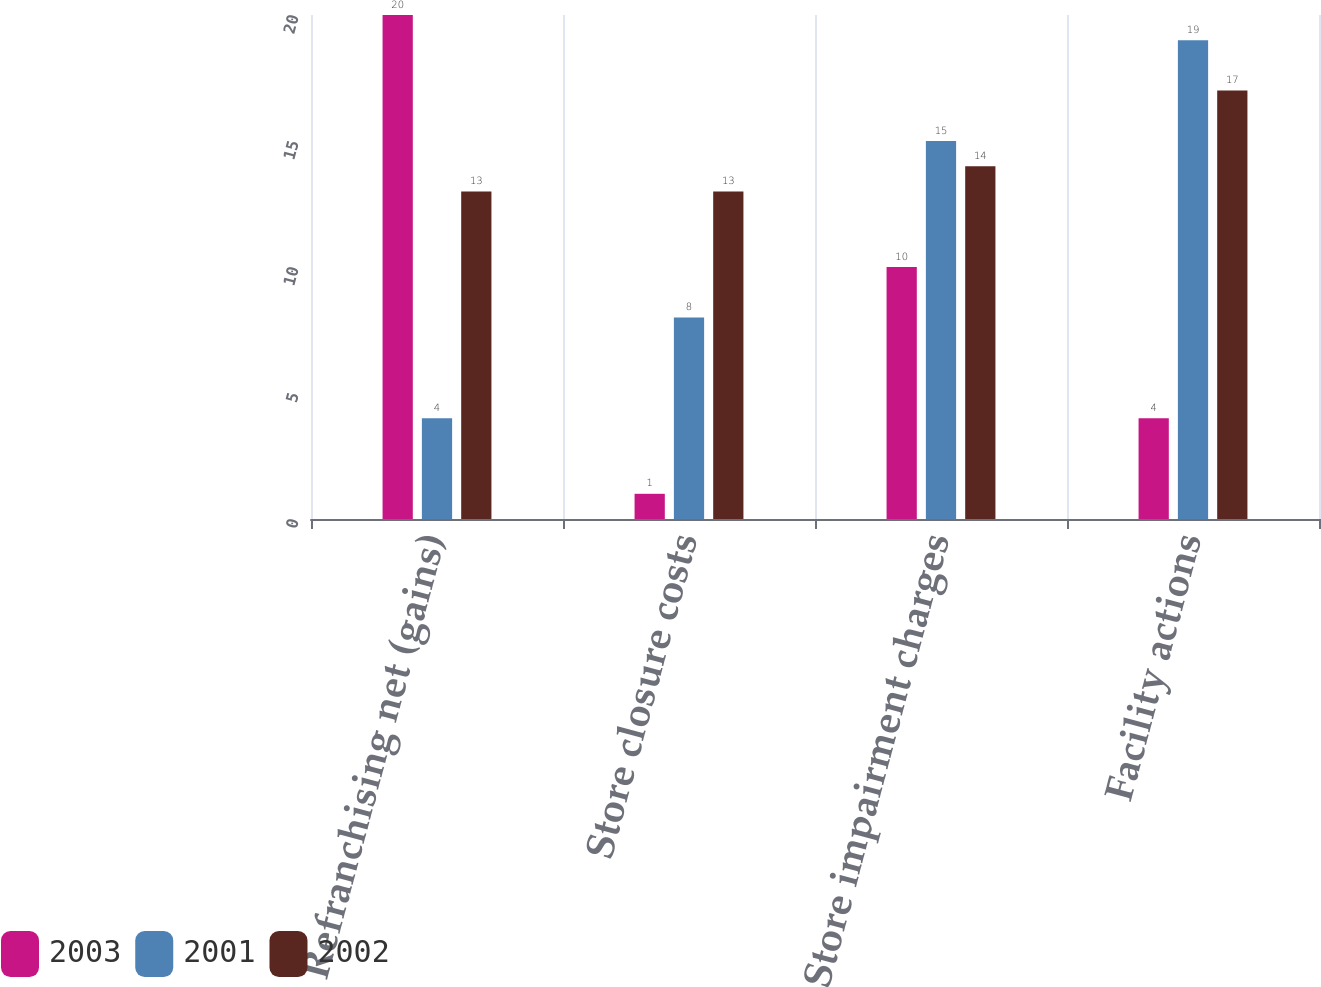Convert chart to OTSL. <chart><loc_0><loc_0><loc_500><loc_500><stacked_bar_chart><ecel><fcel>Refranchising net (gains)<fcel>Store closure costs<fcel>Store impairment charges<fcel>Facility actions<nl><fcel>2003<fcel>20<fcel>1<fcel>10<fcel>4<nl><fcel>2001<fcel>4<fcel>8<fcel>15<fcel>19<nl><fcel>2002<fcel>13<fcel>13<fcel>14<fcel>17<nl></chart> 